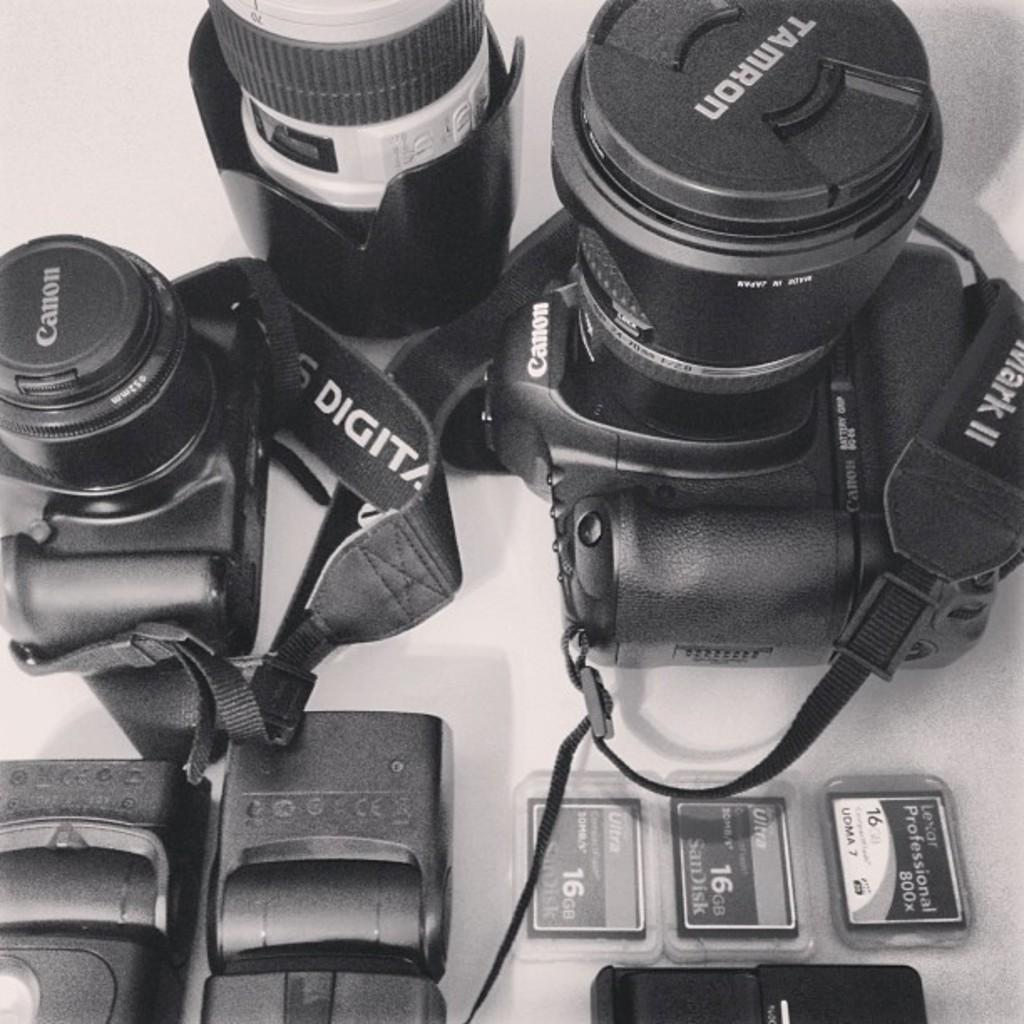What type of equipment is visible in the image? There are cameras in the image. What other items can be seen in the image besides the cameras? There are cards in the image. Can you describe the surface on which the cameras and cards are placed? The cameras and cards are placed on a white surface in the image. How far away is the person standing from the cameras in the image? There is no person present in the image, so it is not possible to determine the distance between a person and the cameras. 